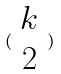Convert formula to latex. <formula><loc_0><loc_0><loc_500><loc_500>( \begin{array} { c } k \\ 2 \end{array} )</formula> 